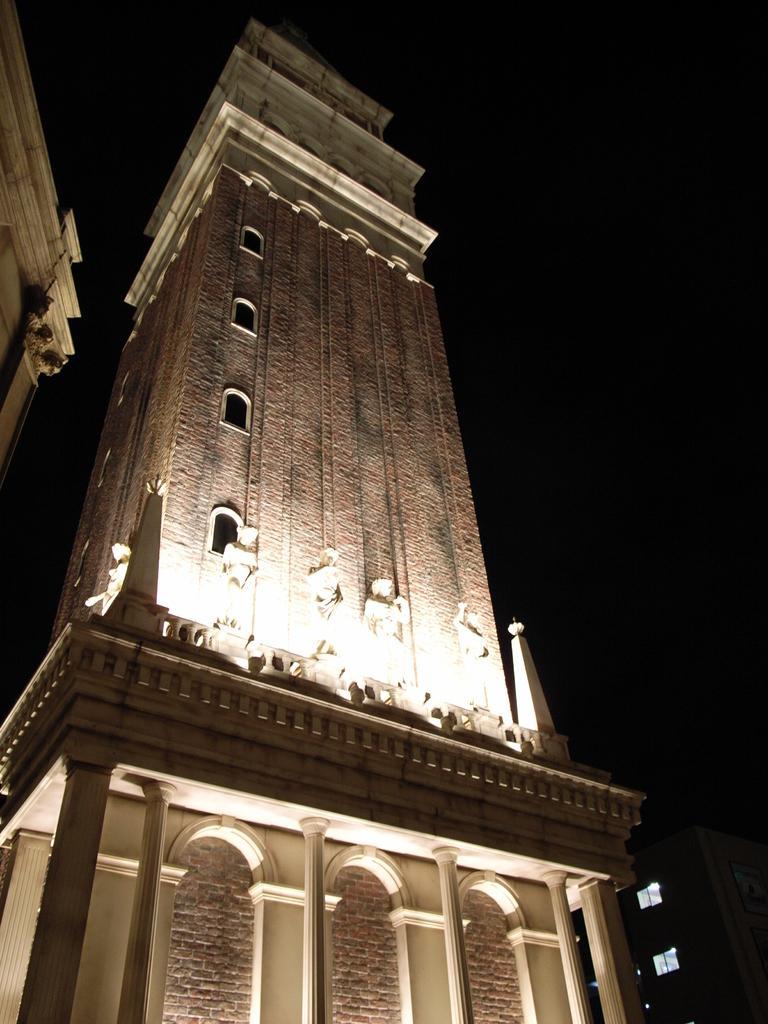In one or two sentences, can you explain what this image depicts? In this picture I can see few statues in the middle, there is a building with lights. On the right side there is the sky. 